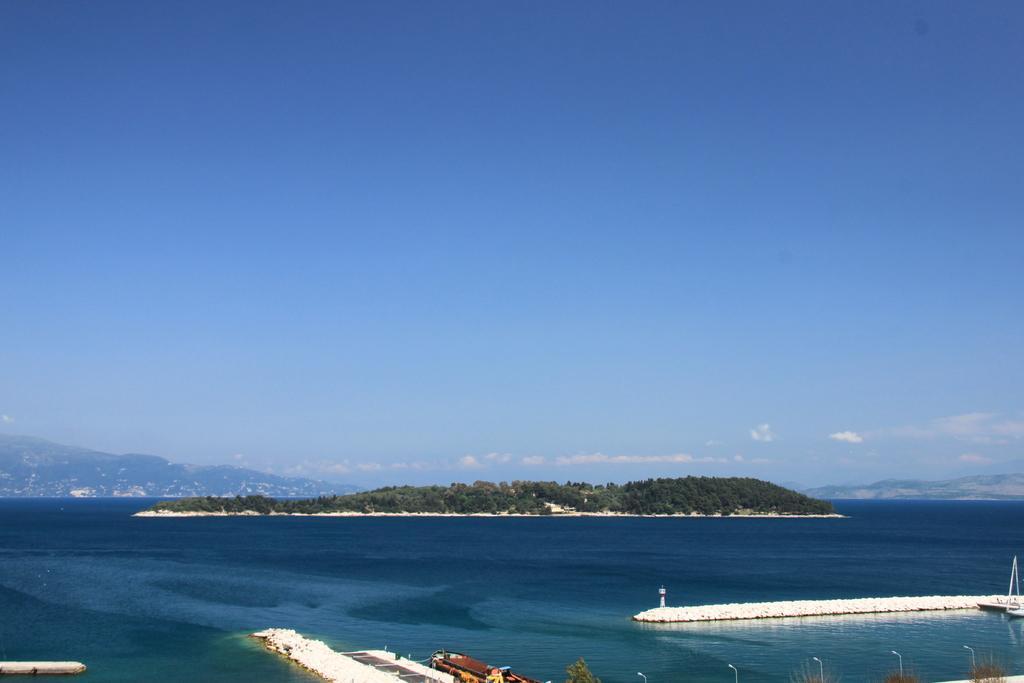How would you summarize this image in a sentence or two? In this image I can see boats in the water, fence and light poles. In the background I can see trees, mountains, buildings and the sky. This image is taken may be near the ocean. 